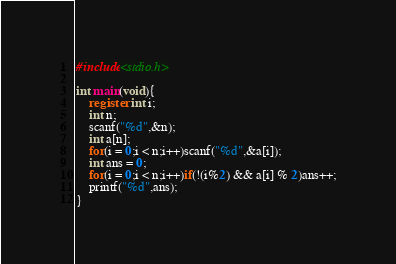Convert code to text. <code><loc_0><loc_0><loc_500><loc_500><_C_>#include<stdio.h>

int main(void){
    register int i;
    int n;
    scanf("%d",&n);
    int a[n];
    for(i = 0;i < n;i++)scanf("%d",&a[i]);
    int ans = 0;
    for(i = 0;i < n;i++)if(!(i%2) && a[i] % 2)ans++;
    printf("%d",ans);
}</code> 